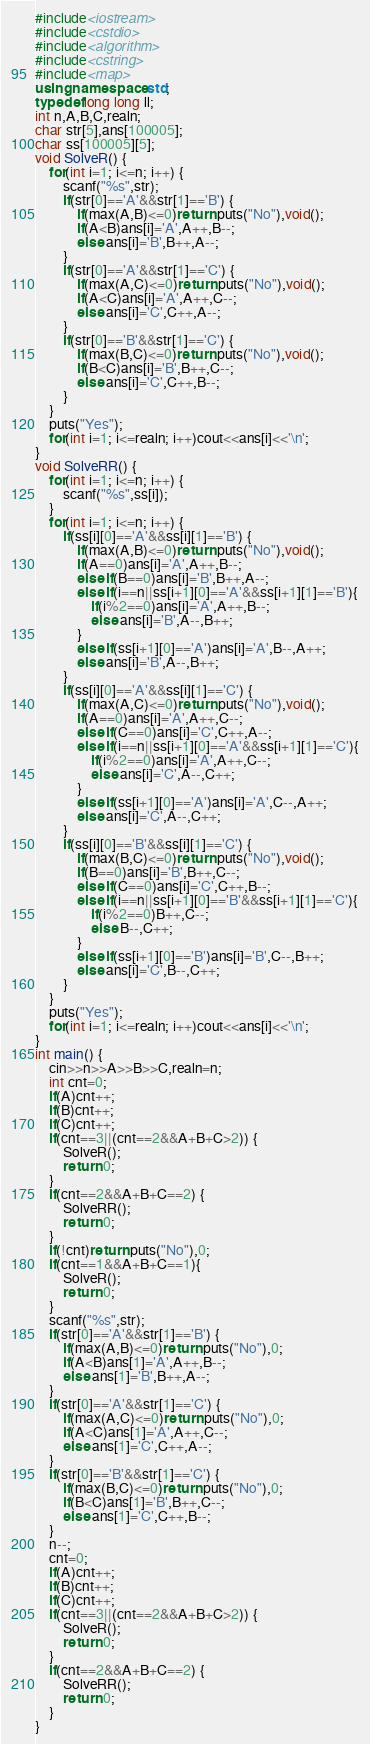Convert code to text. <code><loc_0><loc_0><loc_500><loc_500><_C++_>#include<iostream>
#include<cstdio>
#include<algorithm>
#include<cstring>
#include<map>
using namespace std;
typedef long long ll;
int n,A,B,C,realn;
char str[5],ans[100005];
char ss[100005][5];
void SolveR() {
	for(int i=1; i<=n; i++) {
		scanf("%s",str);
		if(str[0]=='A'&&str[1]=='B') {
			if(max(A,B)<=0)return puts("No"),void();
			if(A<B)ans[i]='A',A++,B--;
			else ans[i]='B',B++,A--;
		}
		if(str[0]=='A'&&str[1]=='C') {
			if(max(A,C)<=0)return puts("No"),void();
			if(A<C)ans[i]='A',A++,C--;
			else ans[i]='C',C++,A--;
		}
		if(str[0]=='B'&&str[1]=='C') {
			if(max(B,C)<=0)return puts("No"),void();
			if(B<C)ans[i]='B',B++,C--;
			else ans[i]='C',C++,B--;
		}
	}
	puts("Yes");
	for(int i=1; i<=realn; i++)cout<<ans[i]<<'\n';
}
void SolveRR() {
	for(int i=1; i<=n; i++) {
		scanf("%s",ss[i]);
	}
	for(int i=1; i<=n; i++) {
		if(ss[i][0]=='A'&&ss[i][1]=='B') {
			if(max(A,B)<=0)return puts("No"),void();
			if(A==0)ans[i]='A',A++,B--;
			else if(B==0)ans[i]='B',B++,A--;
			else if(i==n||ss[i+1][0]=='A'&&ss[i+1][1]=='B'){
				if(i%2==0)ans[i]='A',A++,B--;
				else ans[i]='B',A--,B++;
			}
			else if(ss[i+1][0]=='A')ans[i]='A',B--,A++;
			else ans[i]='B',A--,B++;
		}
		if(ss[i][0]=='A'&&ss[i][1]=='C') {
			if(max(A,C)<=0)return puts("No"),void();
			if(A==0)ans[i]='A',A++,C--;
			else if(C==0)ans[i]='C',C++,A--;
			else if(i==n||ss[i+1][0]=='A'&&ss[i+1][1]=='C'){
				if(i%2==0)ans[i]='A',A++,C--;
				else ans[i]='C',A--,C++;
			}
			else if(ss[i+1][0]=='A')ans[i]='A',C--,A++;
			else ans[i]='C',A--,C++;
		}
		if(ss[i][0]=='B'&&ss[i][1]=='C') {
			if(max(B,C)<=0)return puts("No"),void();
			if(B==0)ans[i]='B',B++,C--;
			else if(C==0)ans[i]='C',C++,B--;
			else if(i==n||ss[i+1][0]=='B'&&ss[i+1][1]=='C'){
				if(i%2==0)B++,C--;
				else B--,C++;
			}
			else if(ss[i+1][0]=='B')ans[i]='B',C--,B++;
			else ans[i]='C',B--,C++;
		}
	}
	puts("Yes");
	for(int i=1; i<=realn; i++)cout<<ans[i]<<'\n';
}
int main() {
	cin>>n>>A>>B>>C,realn=n;
	int cnt=0;
	if(A)cnt++;
	if(B)cnt++;
	if(C)cnt++;
	if(cnt==3||(cnt==2&&A+B+C>2)) {
		SolveR();
		return 0;
	}
	if(cnt==2&&A+B+C==2) {
		SolveRR();
		return 0;
	}
	if(!cnt)return puts("No"),0;
	if(cnt==1&&A+B+C==1){
		SolveR();
		return 0;
	}
	scanf("%s",str);
	if(str[0]=='A'&&str[1]=='B') {
		if(max(A,B)<=0)return puts("No"),0;
		if(A<B)ans[1]='A',A++,B--;
		else ans[1]='B',B++,A--;
	}
	if(str[0]=='A'&&str[1]=='C') {
		if(max(A,C)<=0)return puts("No"),0;
		if(A<C)ans[1]='A',A++,C--;
		else ans[1]='C',C++,A--;
	} 
	if(str[0]=='B'&&str[1]=='C') {
		if(max(B,C)<=0)return puts("No"),0;
		if(B<C)ans[1]='B',B++,C--;
		else ans[1]='C',C++,B--;
	}
	n--;
	cnt=0;
	if(A)cnt++;
	if(B)cnt++;
	if(C)cnt++;
	if(cnt==3||(cnt==2&&A+B+C>2)) {
		SolveR();
		return 0;
	}
	if(cnt==2&&A+B+C==2) {
		SolveRR();
		return 0;
	}
}
</code> 